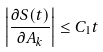Convert formula to latex. <formula><loc_0><loc_0><loc_500><loc_500>\left | \frac { \partial S ( t ) } { \partial A _ { k } } \right | \leq C _ { 1 } t</formula> 